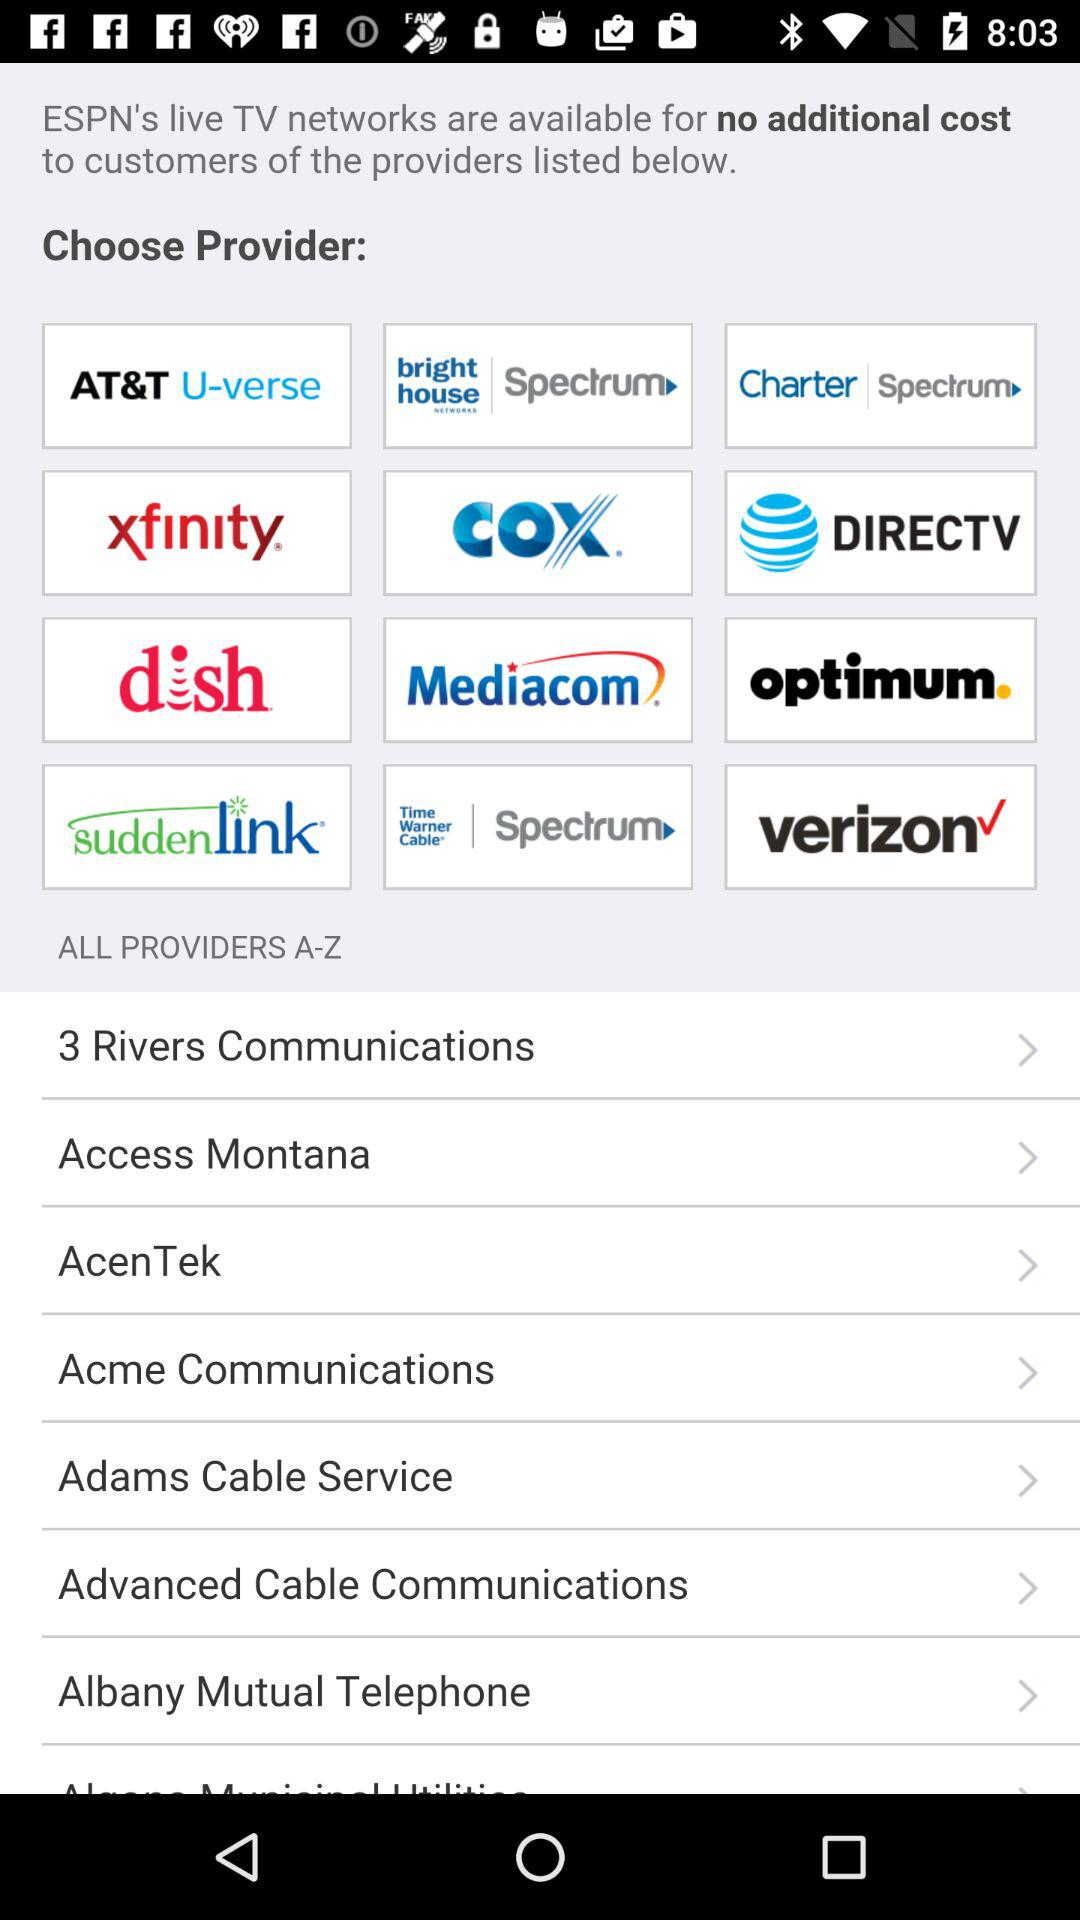What are the names of the service providers? The service providers are "AT&T U-verse", "Bright House Networks Spectrum", "Charter Spectrum", "Xfinity", "Cox", "AT&T DIRECTV", "Dish", "Mediacom", "Optimum", "Suddenlink", "Time Warner Cable Spectrum", "Verizon", "3 Rivers Communications", "Access Montana", "AcenTek", "Acme Communications", "Adams Cable Service", "Advanced Cable Communications" and "Albany Mutual Telephone". 